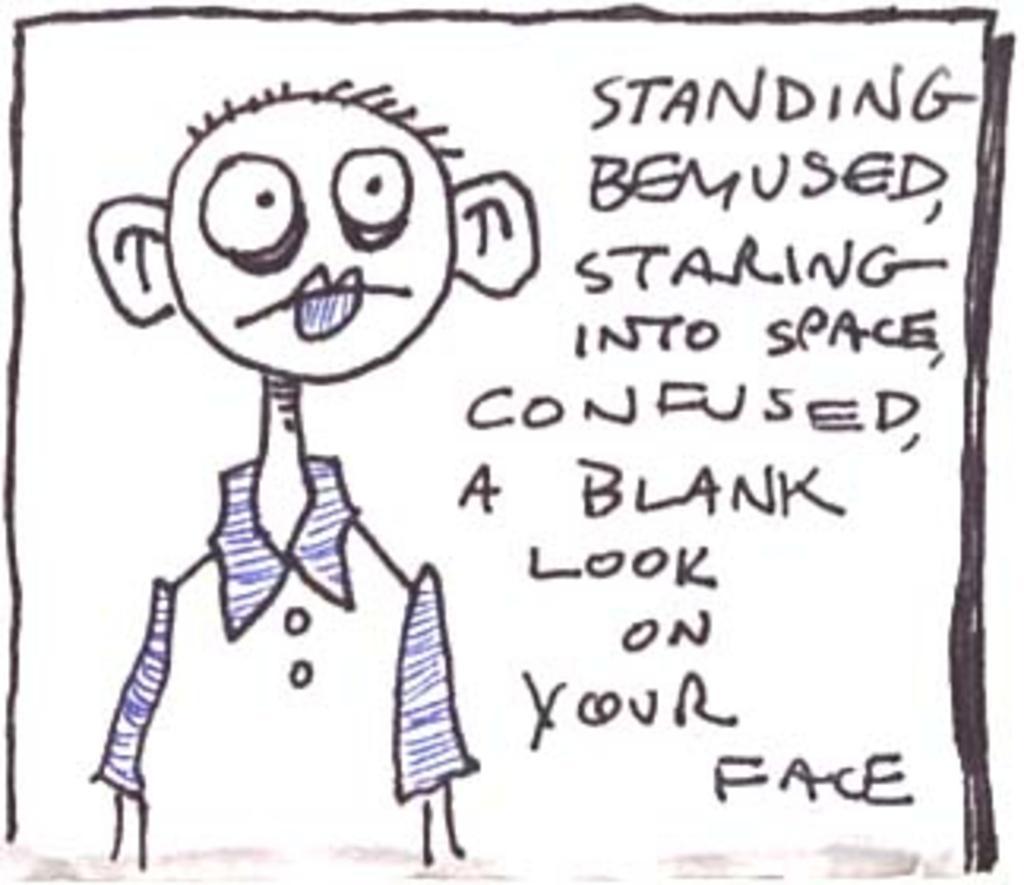How would you summarize this image in a sentence or two? There is a cartoon drawing with something written on a paper. 